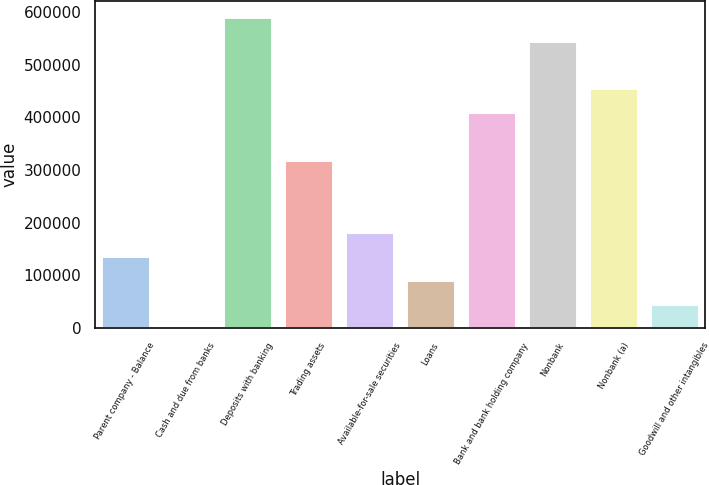Convert chart to OTSL. <chart><loc_0><loc_0><loc_500><loc_500><bar_chart><fcel>Parent company - Balance<fcel>Cash and due from banks<fcel>Deposits with banking<fcel>Trading assets<fcel>Available-for-sale securities<fcel>Loans<fcel>Bank and bank holding company<fcel>Nonbank<fcel>Nonbank (a)<fcel>Goodwill and other intangibles<nl><fcel>136510<fcel>132<fcel>591104<fcel>318348<fcel>181970<fcel>91050.8<fcel>409267<fcel>545645<fcel>454726<fcel>45591.4<nl></chart> 